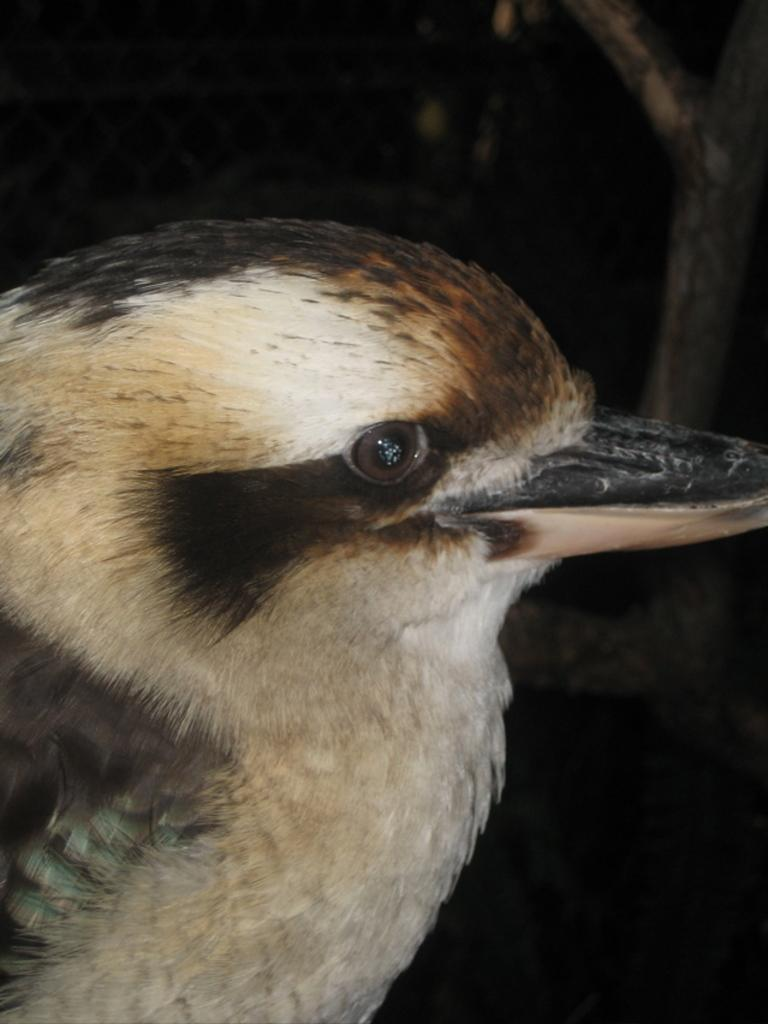What type of animal can be seen in the image? There is a bird in the image. What is the color of the background in the image? The background of the image is dark. What type of afterthought can be seen in the image? There is no afterthought present in the image; it features a bird against a dark background. What type of teeth can be seen in the image? There are no teeth visible in the image, as it features a bird against a dark background. 